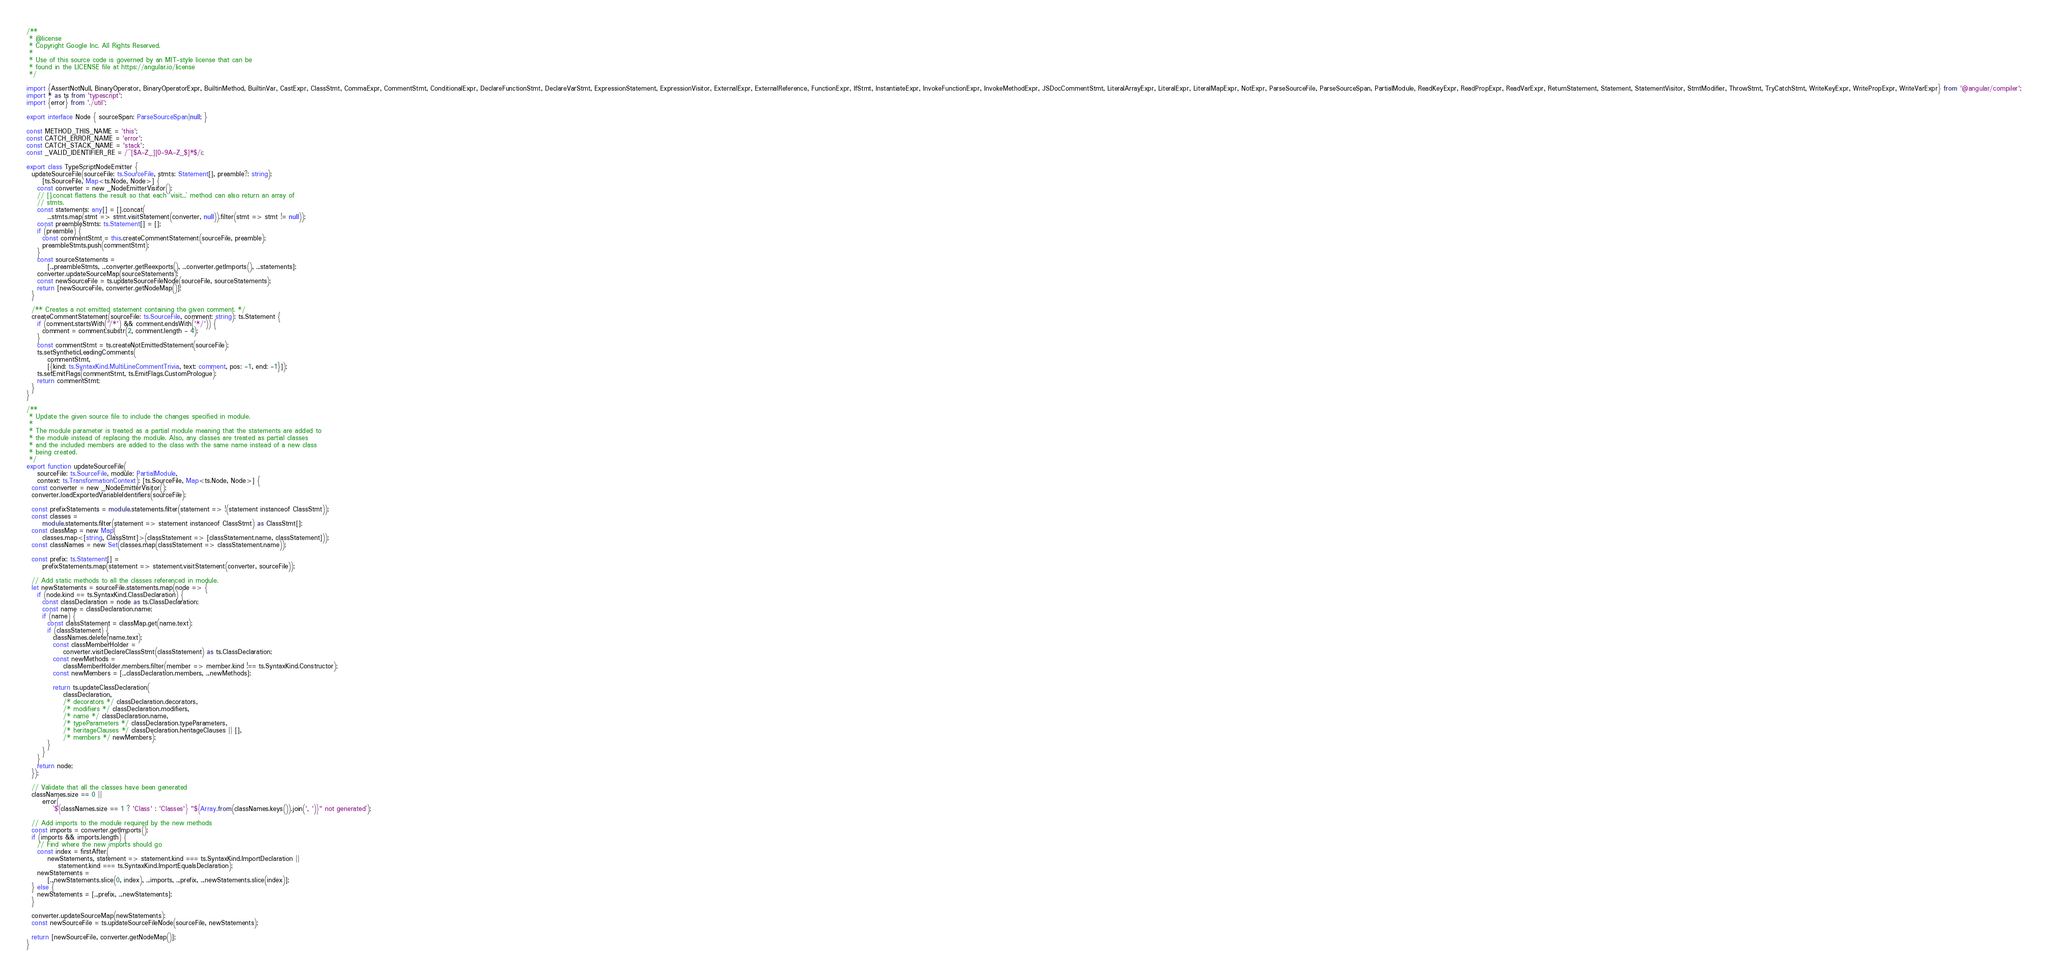Convert code to text. <code><loc_0><loc_0><loc_500><loc_500><_TypeScript_>/**
 * @license
 * Copyright Google Inc. All Rights Reserved.
 *
 * Use of this source code is governed by an MIT-style license that can be
 * found in the LICENSE file at https://angular.io/license
 */

import {AssertNotNull, BinaryOperator, BinaryOperatorExpr, BuiltinMethod, BuiltinVar, CastExpr, ClassStmt, CommaExpr, CommentStmt, ConditionalExpr, DeclareFunctionStmt, DeclareVarStmt, ExpressionStatement, ExpressionVisitor, ExternalExpr, ExternalReference, FunctionExpr, IfStmt, InstantiateExpr, InvokeFunctionExpr, InvokeMethodExpr, JSDocCommentStmt, LiteralArrayExpr, LiteralExpr, LiteralMapExpr, NotExpr, ParseSourceFile, ParseSourceSpan, PartialModule, ReadKeyExpr, ReadPropExpr, ReadVarExpr, ReturnStatement, Statement, StatementVisitor, StmtModifier, ThrowStmt, TryCatchStmt, WriteKeyExpr, WritePropExpr, WriteVarExpr} from '@angular/compiler';
import * as ts from 'typescript';
import {error} from './util';

export interface Node { sourceSpan: ParseSourceSpan|null; }

const METHOD_THIS_NAME = 'this';
const CATCH_ERROR_NAME = 'error';
const CATCH_STACK_NAME = 'stack';
const _VALID_IDENTIFIER_RE = /^[$A-Z_][0-9A-Z_$]*$/i;

export class TypeScriptNodeEmitter {
  updateSourceFile(sourceFile: ts.SourceFile, stmts: Statement[], preamble?: string):
      [ts.SourceFile, Map<ts.Node, Node>] {
    const converter = new _NodeEmitterVisitor();
    // [].concat flattens the result so that each `visit...` method can also return an array of
    // stmts.
    const statements: any[] = [].concat(
        ...stmts.map(stmt => stmt.visitStatement(converter, null)).filter(stmt => stmt != null));
    const preambleStmts: ts.Statement[] = [];
    if (preamble) {
      const commentStmt = this.createCommentStatement(sourceFile, preamble);
      preambleStmts.push(commentStmt);
    }
    const sourceStatements =
        [...preambleStmts, ...converter.getReexports(), ...converter.getImports(), ...statements];
    converter.updateSourceMap(sourceStatements);
    const newSourceFile = ts.updateSourceFileNode(sourceFile, sourceStatements);
    return [newSourceFile, converter.getNodeMap()];
  }

  /** Creates a not emitted statement containing the given comment. */
  createCommentStatement(sourceFile: ts.SourceFile, comment: string): ts.Statement {
    if (comment.startsWith('/*') && comment.endsWith('*/')) {
      comment = comment.substr(2, comment.length - 4);
    }
    const commentStmt = ts.createNotEmittedStatement(sourceFile);
    ts.setSyntheticLeadingComments(
        commentStmt,
        [{kind: ts.SyntaxKind.MultiLineCommentTrivia, text: comment, pos: -1, end: -1}]);
    ts.setEmitFlags(commentStmt, ts.EmitFlags.CustomPrologue);
    return commentStmt;
  }
}

/**
 * Update the given source file to include the changes specified in module.
 *
 * The module parameter is treated as a partial module meaning that the statements are added to
 * the module instead of replacing the module. Also, any classes are treated as partial classes
 * and the included members are added to the class with the same name instead of a new class
 * being created.
 */
export function updateSourceFile(
    sourceFile: ts.SourceFile, module: PartialModule,
    context: ts.TransformationContext): [ts.SourceFile, Map<ts.Node, Node>] {
  const converter = new _NodeEmitterVisitor();
  converter.loadExportedVariableIdentifiers(sourceFile);

  const prefixStatements = module.statements.filter(statement => !(statement instanceof ClassStmt));
  const classes =
      module.statements.filter(statement => statement instanceof ClassStmt) as ClassStmt[];
  const classMap = new Map(
      classes.map<[string, ClassStmt]>(classStatement => [classStatement.name, classStatement]));
  const classNames = new Set(classes.map(classStatement => classStatement.name));

  const prefix: ts.Statement[] =
      prefixStatements.map(statement => statement.visitStatement(converter, sourceFile));

  // Add static methods to all the classes referenced in module.
  let newStatements = sourceFile.statements.map(node => {
    if (node.kind == ts.SyntaxKind.ClassDeclaration) {
      const classDeclaration = node as ts.ClassDeclaration;
      const name = classDeclaration.name;
      if (name) {
        const classStatement = classMap.get(name.text);
        if (classStatement) {
          classNames.delete(name.text);
          const classMemberHolder =
              converter.visitDeclareClassStmt(classStatement) as ts.ClassDeclaration;
          const newMethods =
              classMemberHolder.members.filter(member => member.kind !== ts.SyntaxKind.Constructor);
          const newMembers = [...classDeclaration.members, ...newMethods];

          return ts.updateClassDeclaration(
              classDeclaration,
              /* decorators */ classDeclaration.decorators,
              /* modifiers */ classDeclaration.modifiers,
              /* name */ classDeclaration.name,
              /* typeParameters */ classDeclaration.typeParameters,
              /* heritageClauses */ classDeclaration.heritageClauses || [],
              /* members */ newMembers);
        }
      }
    }
    return node;
  });

  // Validate that all the classes have been generated
  classNames.size == 0 ||
      error(
          `${classNames.size == 1 ? 'Class' : 'Classes'} "${Array.from(classNames.keys()).join(', ')}" not generated`);

  // Add imports to the module required by the new methods
  const imports = converter.getImports();
  if (imports && imports.length) {
    // Find where the new imports should go
    const index = firstAfter(
        newStatements, statement => statement.kind === ts.SyntaxKind.ImportDeclaration ||
            statement.kind === ts.SyntaxKind.ImportEqualsDeclaration);
    newStatements =
        [...newStatements.slice(0, index), ...imports, ...prefix, ...newStatements.slice(index)];
  } else {
    newStatements = [...prefix, ...newStatements];
  }

  converter.updateSourceMap(newStatements);
  const newSourceFile = ts.updateSourceFileNode(sourceFile, newStatements);

  return [newSourceFile, converter.getNodeMap()];
}
</code> 